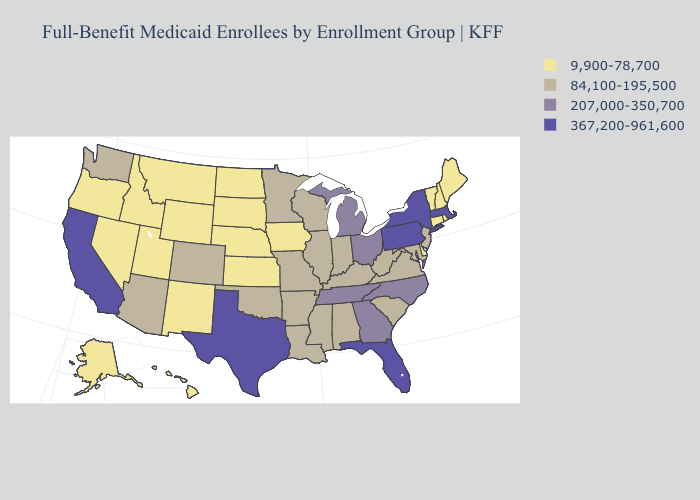What is the value of Oregon?
Answer briefly. 9,900-78,700. Name the states that have a value in the range 367,200-961,600?
Quick response, please. California, Florida, Massachusetts, New York, Pennsylvania, Texas. Name the states that have a value in the range 367,200-961,600?
Answer briefly. California, Florida, Massachusetts, New York, Pennsylvania, Texas. Does Tennessee have a lower value than California?
Answer briefly. Yes. Is the legend a continuous bar?
Concise answer only. No. What is the value of Washington?
Quick response, please. 84,100-195,500. Does Washington have the lowest value in the West?
Be succinct. No. Name the states that have a value in the range 84,100-195,500?
Concise answer only. Alabama, Arizona, Arkansas, Colorado, Illinois, Indiana, Kentucky, Louisiana, Maryland, Minnesota, Mississippi, Missouri, New Jersey, Oklahoma, South Carolina, Virginia, Washington, West Virginia, Wisconsin. What is the value of New Hampshire?
Short answer required. 9,900-78,700. Which states have the lowest value in the West?
Short answer required. Alaska, Hawaii, Idaho, Montana, Nevada, New Mexico, Oregon, Utah, Wyoming. Which states have the lowest value in the USA?
Quick response, please. Alaska, Connecticut, Delaware, Hawaii, Idaho, Iowa, Kansas, Maine, Montana, Nebraska, Nevada, New Hampshire, New Mexico, North Dakota, Oregon, Rhode Island, South Dakota, Utah, Vermont, Wyoming. Does South Dakota have a lower value than South Carolina?
Be succinct. Yes. Does New York have the highest value in the USA?
Be succinct. Yes. Does Minnesota have a higher value than Illinois?
Short answer required. No. Does the map have missing data?
Give a very brief answer. No. 